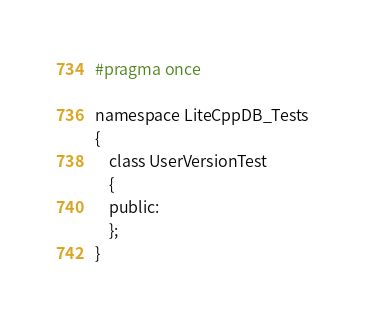Convert code to text. <code><loc_0><loc_0><loc_500><loc_500><_C_>#pragma once

namespace LiteCppDB_Tests
{
	class UserVersionTest
	{
	public:
	};
}</code> 